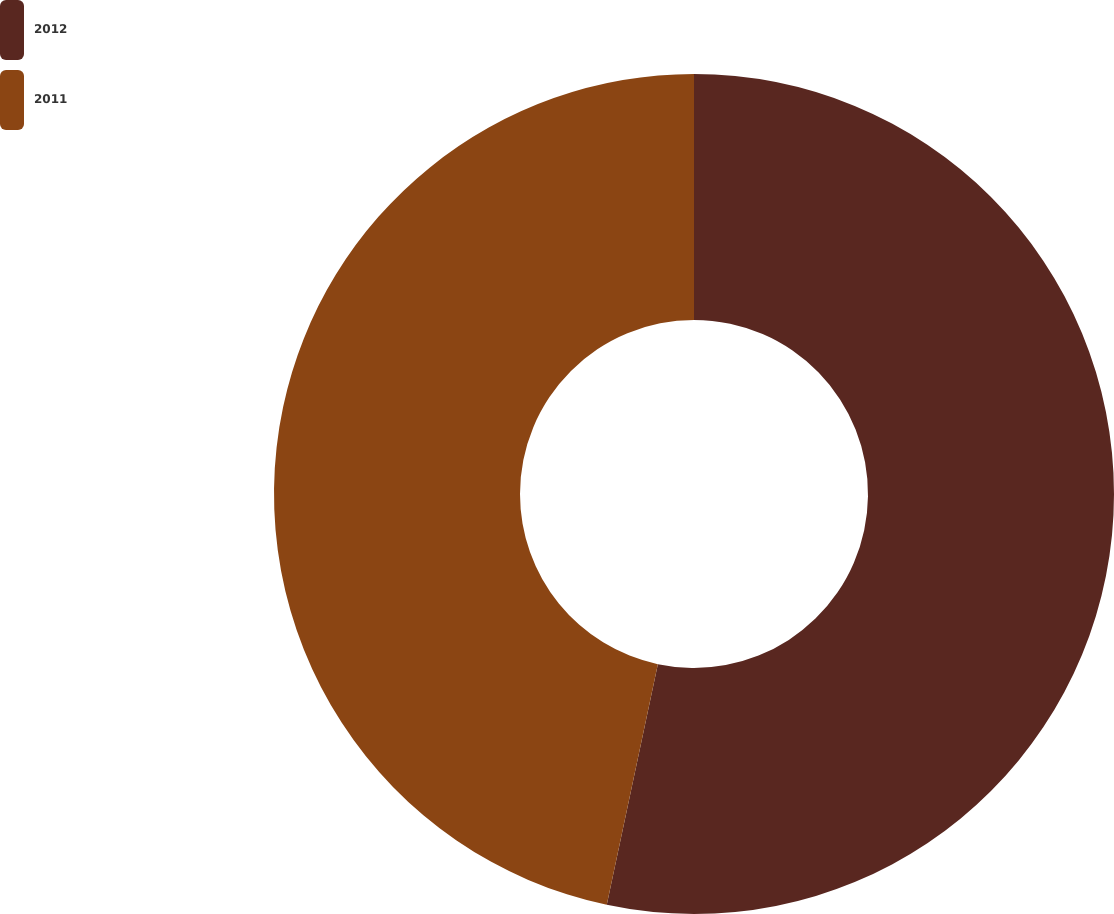Convert chart to OTSL. <chart><loc_0><loc_0><loc_500><loc_500><pie_chart><fcel>2012<fcel>2011<nl><fcel>53.33%<fcel>46.67%<nl></chart> 